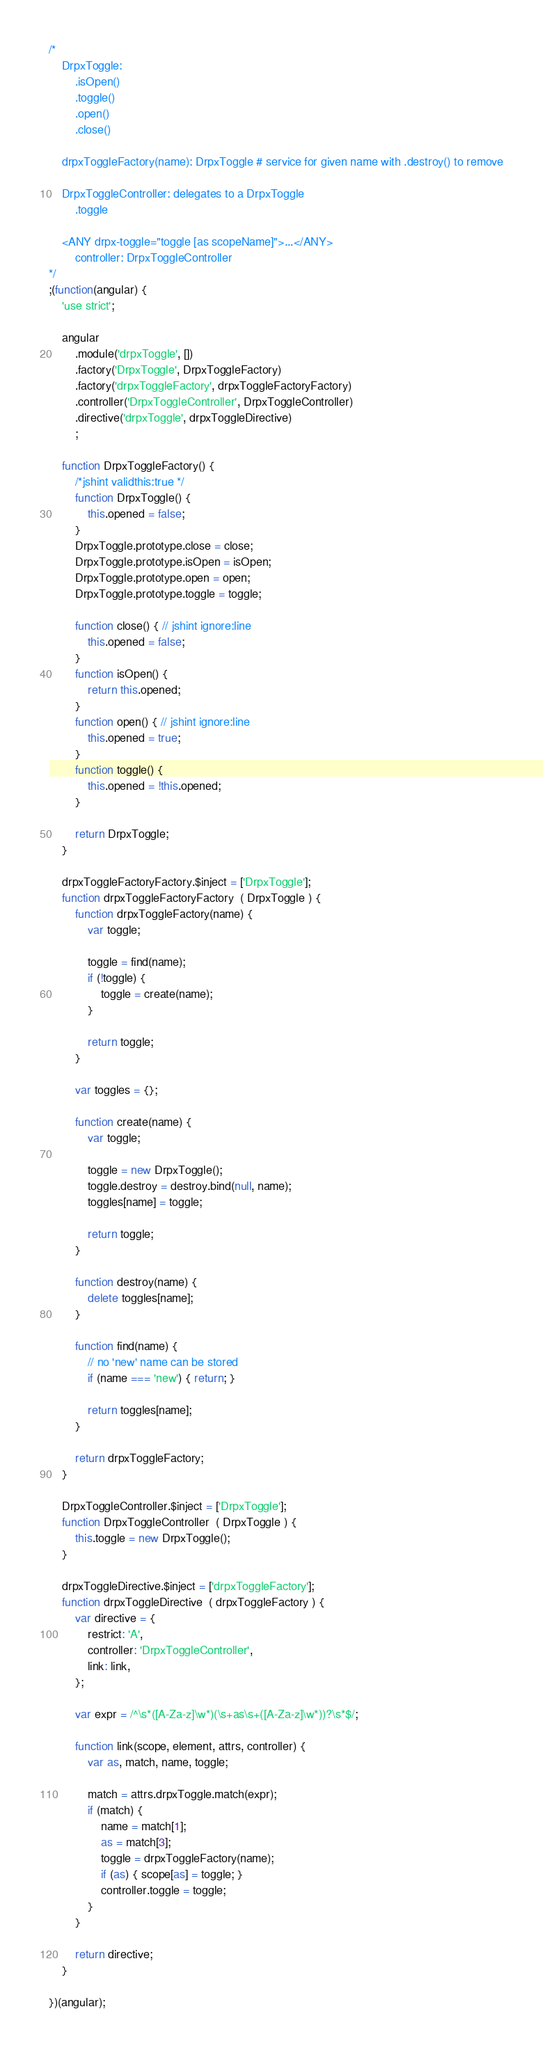<code> <loc_0><loc_0><loc_500><loc_500><_JavaScript_>/*
	DrpxToggle:
		.isOpen()
		.toggle()
		.open()
		.close()

	drpxToggleFactory(name): DrpxToggle # service for given name with .destroy() to remove

	DrpxToggleController: delegates to a DrpxToggle
		.toggle

	<ANY drpx-toggle="toggle [as scopeName]">...</ANY>
		controller: DrpxToggleController
*/
;(function(angular) {
	'use strict';

	angular
		.module('drpxToggle', [])
		.factory('DrpxToggle', DrpxToggleFactory)
		.factory('drpxToggleFactory', drpxToggleFactoryFactory)
		.controller('DrpxToggleController', DrpxToggleController)
		.directive('drpxToggle', drpxToggleDirective)
		;

	function DrpxToggleFactory() {
		/*jshint validthis:true */
		function DrpxToggle() {
			this.opened = false;
		}
		DrpxToggle.prototype.close = close;
		DrpxToggle.prototype.isOpen = isOpen;
		DrpxToggle.prototype.open = open;
		DrpxToggle.prototype.toggle = toggle;

		function close() { // jshint ignore:line
			this.opened = false;
		}
		function isOpen() {
			return this.opened;
		}
		function open() { // jshint ignore:line
			this.opened = true;
		}
		function toggle() {
			this.opened = !this.opened;
		}

		return DrpxToggle;
	}

	drpxToggleFactoryFactory.$inject = ['DrpxToggle'];
	function drpxToggleFactoryFactory  ( DrpxToggle ) {
		function drpxToggleFactory(name) {
			var toggle;

			toggle = find(name);
			if (!toggle) {
				toggle = create(name);
			}

			return toggle;
		}

		var toggles = {};

		function create(name) {
			var toggle;

			toggle = new DrpxToggle();
			toggle.destroy = destroy.bind(null, name);
			toggles[name] = toggle;

			return toggle;
		}

		function destroy(name) {
			delete toggles[name];
		}

		function find(name) {
			// no 'new' name can be stored
			if (name === 'new') { return; }
			
			return toggles[name];
		}

		return drpxToggleFactory;
	}

	DrpxToggleController.$inject = ['DrpxToggle'];
	function DrpxToggleController  ( DrpxToggle ) {
		this.toggle = new DrpxToggle();
	}

	drpxToggleDirective.$inject = ['drpxToggleFactory'];
	function drpxToggleDirective  ( drpxToggleFactory ) {
		var directive = {
			restrict: 'A',
			controller: 'DrpxToggleController',
			link: link,
		};

		var expr = /^\s*([A-Za-z]\w*)(\s+as\s+([A-Za-z]\w*))?\s*$/;

		function link(scope, element, attrs, controller) {
			var as, match, name, toggle;

			match = attrs.drpxToggle.match(expr);
			if (match) {
				name = match[1];
				as = match[3];
				toggle = drpxToggleFactory(name);
				if (as) { scope[as] = toggle; }
				controller.toggle = toggle;
			}
		}

		return directive;
	}

})(angular);
</code> 